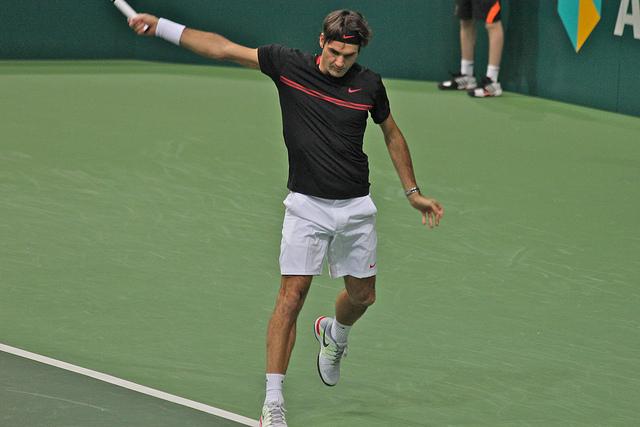What brand is the man's shirt?
Write a very short answer. Nike. Why is one of his feet off the ground?
Answer briefly. Walking. Is the court blue?
Give a very brief answer. No. Are there shadows on the court?
Be succinct. No. What sport is being played?
Concise answer only. Tennis. What color are his shorts?
Be succinct. White. How many tennis players are shown in the picture?
Concise answer only. 1. What does the man do standing against the wall in shorts?
Concise answer only. Fetches ball. How many people are in the picture?
Concise answer only. 2. Has he hit the ball yet?
Concise answer only. No. Are either of his fists clenched?
Quick response, please. No. Is this a doubles or singles match?
Concise answer only. Singles. Do you see a shadow?
Short answer required. No. What is the man wearing on his wrist?
Concise answer only. Wristband. Is he holding the racket with one hand?
Give a very brief answer. Yes. Is this man serving?
Write a very short answer. No. What brand of shoe is the man wearing?
Keep it brief. Nike. Are they playing singles or doubles tennis?
Keep it brief. Singles. What colors are the shoes?
Be succinct. White. What is cast?
Give a very brief answer. Shadow. Is the man bald?
Short answer required. No. What color of shirt is the man wearing?
Be succinct. Black. 